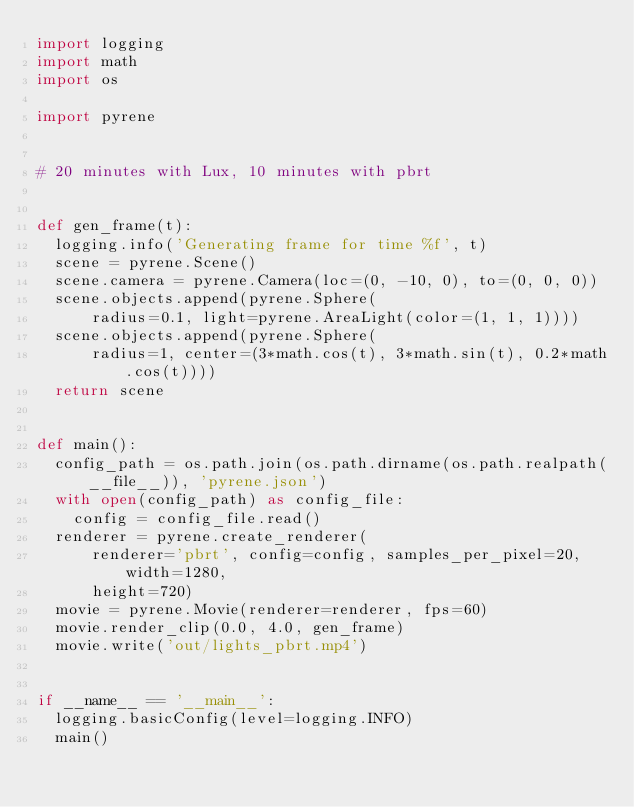<code> <loc_0><loc_0><loc_500><loc_500><_Python_>import logging
import math
import os

import pyrene


# 20 minutes with Lux, 10 minutes with pbrt


def gen_frame(t):
  logging.info('Generating frame for time %f', t)
  scene = pyrene.Scene()
  scene.camera = pyrene.Camera(loc=(0, -10, 0), to=(0, 0, 0))
  scene.objects.append(pyrene.Sphere(
      radius=0.1, light=pyrene.AreaLight(color=(1, 1, 1))))
  scene.objects.append(pyrene.Sphere(
      radius=1, center=(3*math.cos(t), 3*math.sin(t), 0.2*math.cos(t))))
  return scene


def main():
  config_path = os.path.join(os.path.dirname(os.path.realpath(__file__)), 'pyrene.json')
  with open(config_path) as config_file:
    config = config_file.read()
  renderer = pyrene.create_renderer(
      renderer='pbrt', config=config, samples_per_pixel=20, width=1280,
      height=720)
  movie = pyrene.Movie(renderer=renderer, fps=60)
  movie.render_clip(0.0, 4.0, gen_frame)
  movie.write('out/lights_pbrt.mp4')


if __name__ == '__main__':
  logging.basicConfig(level=logging.INFO)
  main()
</code> 